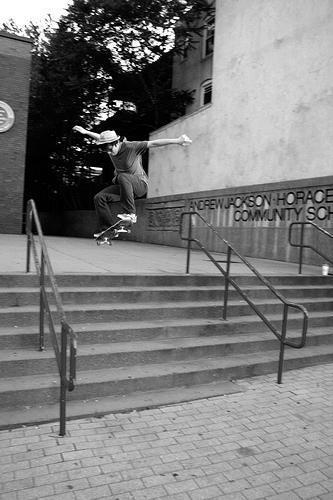How many people are in the photo?
Give a very brief answer. 1. 